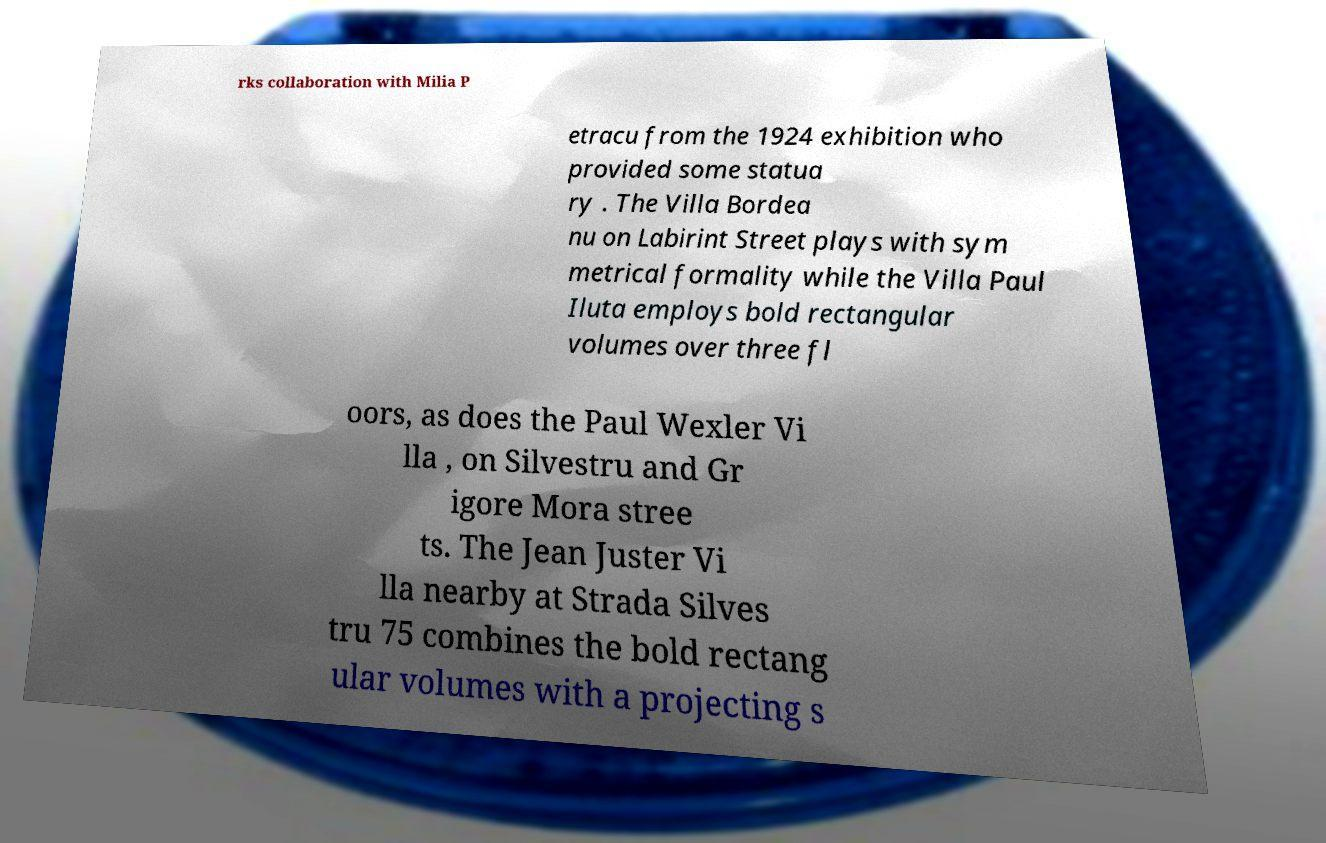There's text embedded in this image that I need extracted. Can you transcribe it verbatim? rks collaboration with Milia P etracu from the 1924 exhibition who provided some statua ry . The Villa Bordea nu on Labirint Street plays with sym metrical formality while the Villa Paul Iluta employs bold rectangular volumes over three fl oors, as does the Paul Wexler Vi lla , on Silvestru and Gr igore Mora stree ts. The Jean Juster Vi lla nearby at Strada Silves tru 75 combines the bold rectang ular volumes with a projecting s 